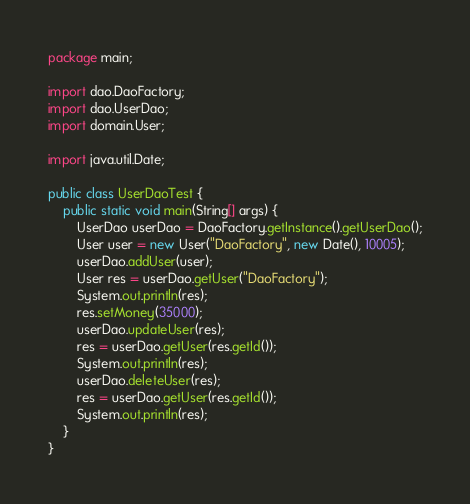Convert code to text. <code><loc_0><loc_0><loc_500><loc_500><_Java_>package main;

import dao.DaoFactory;
import dao.UserDao;
import domain.User;

import java.util.Date;

public class UserDaoTest {
    public static void main(String[] args) {
        UserDao userDao = DaoFactory.getInstance().getUserDao();
        User user = new User("DaoFactory", new Date(), 10005);
        userDao.addUser(user);
        User res = userDao.getUser("DaoFactory");
        System.out.println(res);
        res.setMoney(35000);
        userDao.updateUser(res);
        res = userDao.getUser(res.getId());
        System.out.println(res);
        userDao.deleteUser(res);
        res = userDao.getUser(res.getId());
        System.out.println(res);
    }
}
</code> 